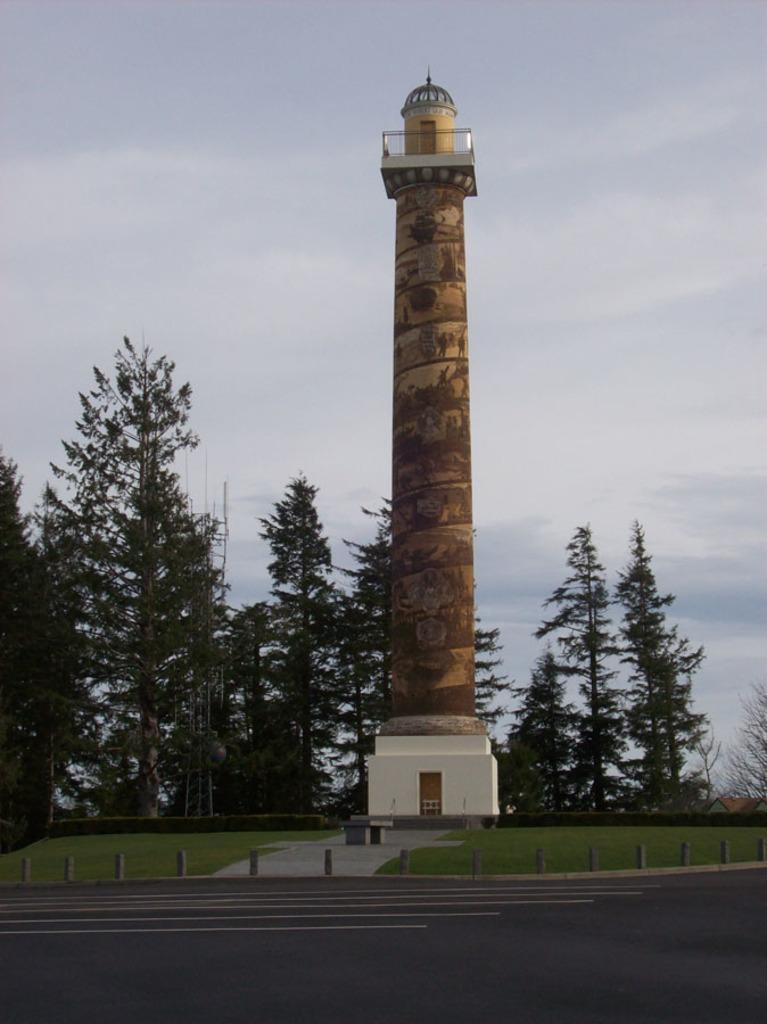What is the main structure in the image? There is a tower in the image. What type of vegetation can be seen on the ground in the image? There are trees and grass on the ground in the image. What type of pathway is visible in the image? There is a road in the image. How would you describe the sky in the image? The sky is cloudy in the image. What type of meat is being grilled on the roof of the tower in the image? There is no meat or grilling activity present in the image. The image only features a tower, trees, grass, a road, and a cloudy sky. 